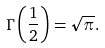<formula> <loc_0><loc_0><loc_500><loc_500>\Gamma \left ( \frac { 1 } { 2 } \right ) = \sqrt { \pi } .</formula> 